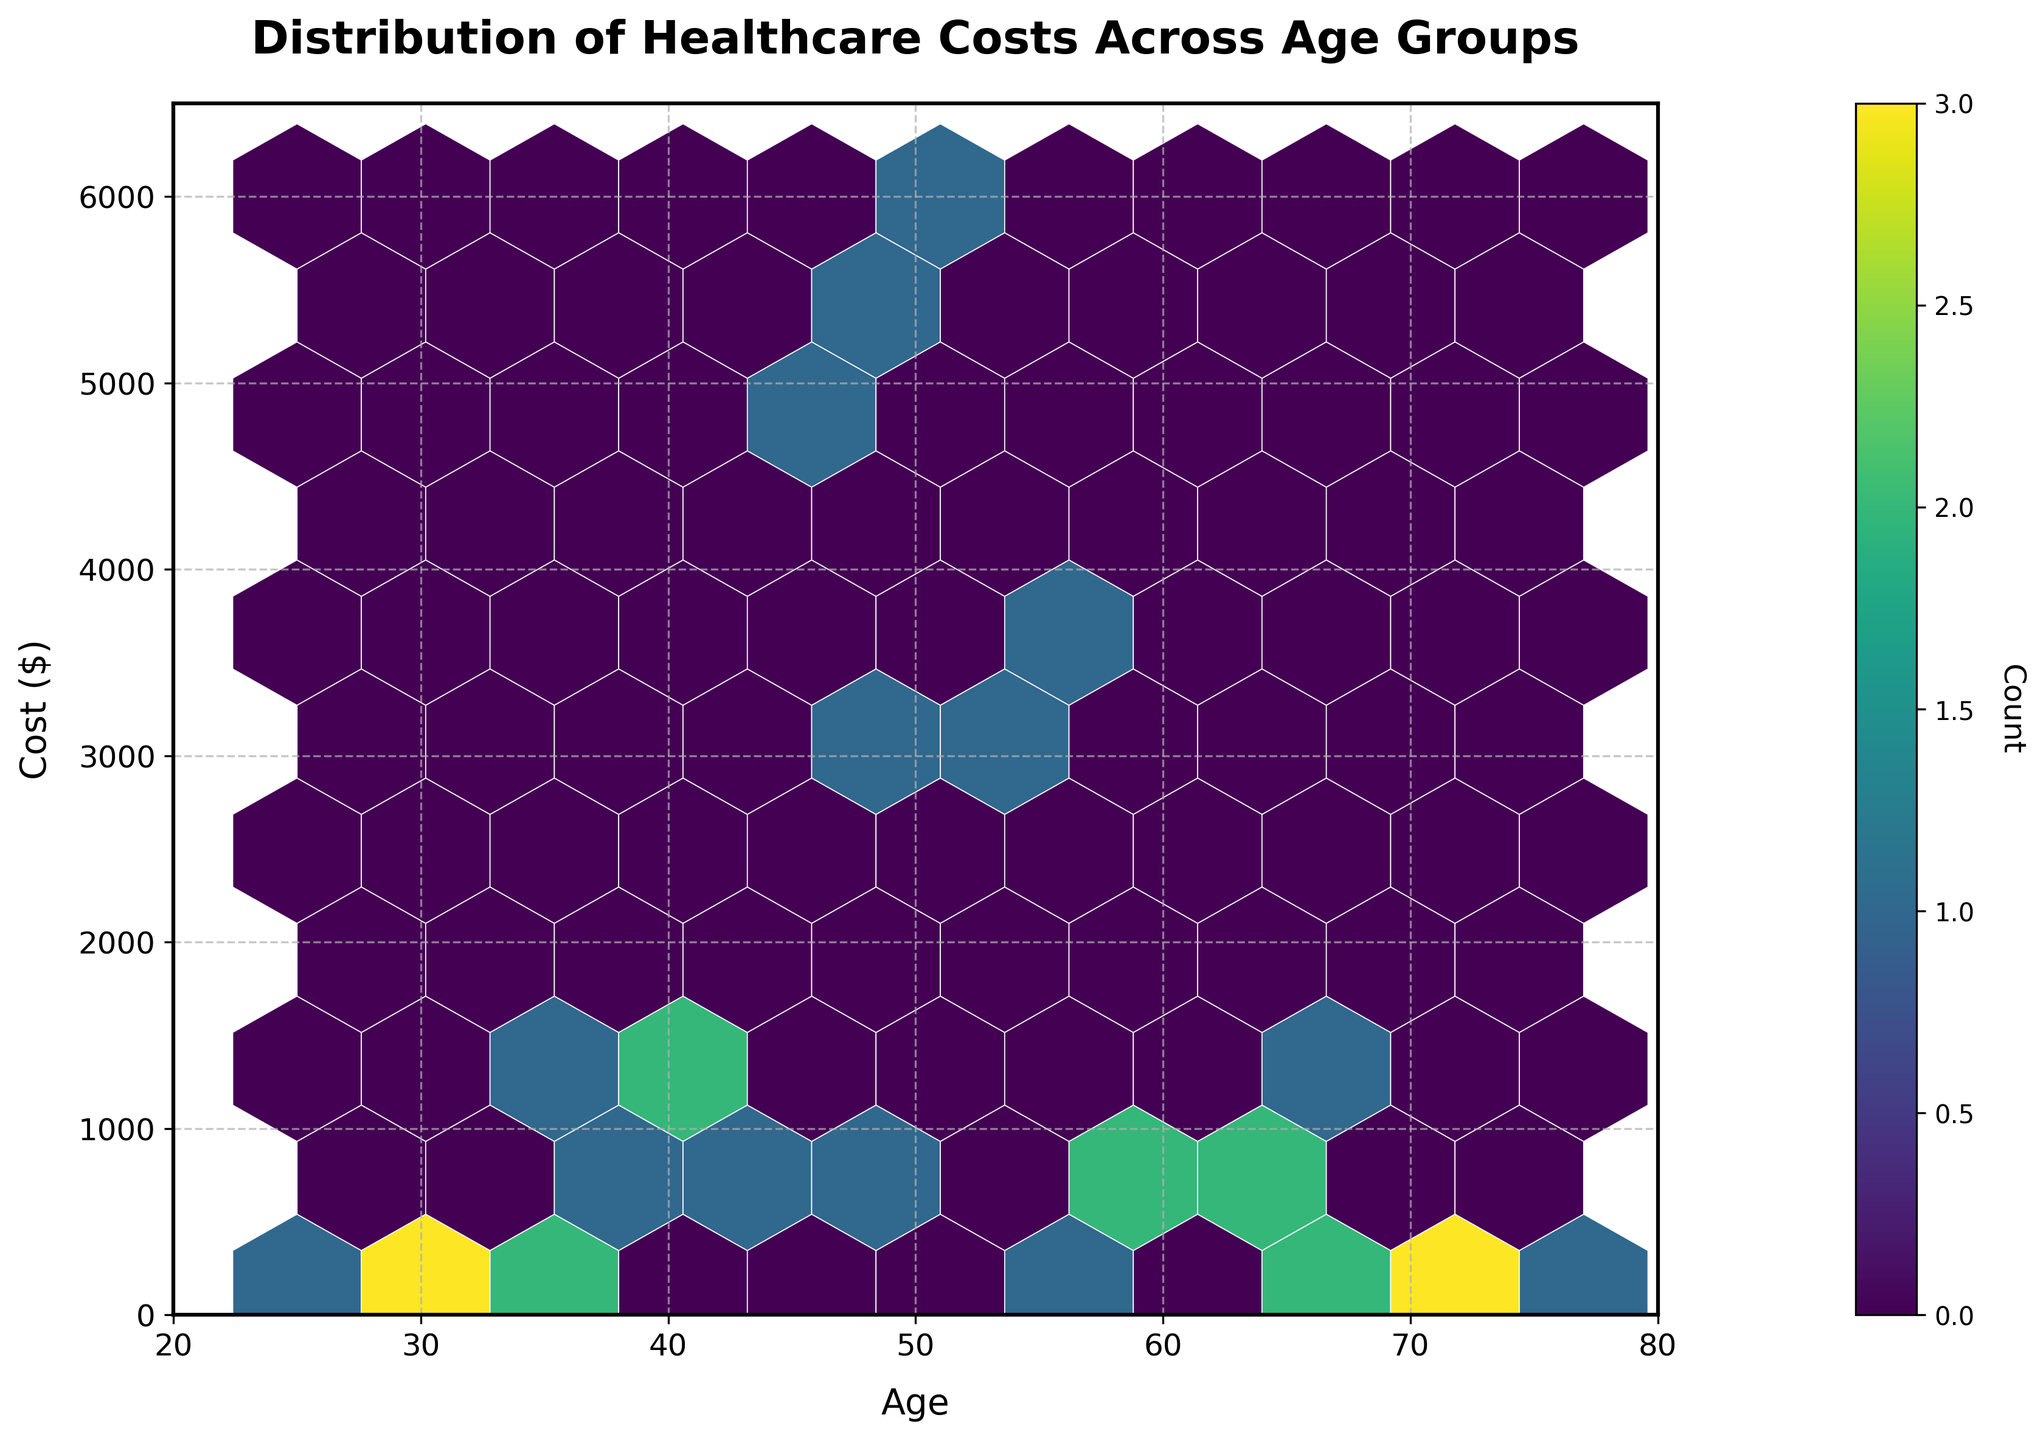What is the title of the figure? The title of the figure is prominently displayed at the top of the plot. It indicates the main subject of the visualization.
Answer: Distribution of Healthcare Costs Across Age Groups What does the color intensity in the plot represent? In hexbin plots, the color intensity usually represents the count of data points within each hexagon. A color bar is present to show this mapping. The more intense the color, the higher the count of data points.
Answer: Count of healthcare costs in each hexagon What are the axes labels in the plot? The axes labels describe what the x-axis and y-axis represent. These labels are usually positioned just outside the axis lines. By looking at these labels, we can understand what dimensions or measures are plotted.
Answer: Age (x-axis) and Cost ($) (y-axis) What is the general trend of healthcare costs with age? To see the trend, look at how the location and concentration of hexagons change along the x-axis (age) and y-axis (cost). Generally, we might observe if costs increase, decrease, or remain constant as age advances.
Answer: Generally, healthcare costs increase with age Which age group has the highest frequency of data points in terms of healthcare costs between $500 - $1500? Look for the most color-intense hexagons in the specified cost range on the y-axis and check the corresponding age groups on the x-axis.
Answer: Age group around 45-50 years Which age group has the lowest overall healthcare costs? Find the range on the x-axis (age) where the y-axis (cost) values are consistently at their minimum, supported by lighter or fewer hexagons.
Answer: 25-30 years Comparing age groups 40 and 70, which one generally incurs higher costs? Focus on the hexagons corresponding to ages 40 and 70. Compare the vertical spread and color intensity of these hexagons to see which age group has higher costs.
Answer: Age group 40 generally incurs higher costs How many age groups have their highest healthcare costs above $4000? Identify hexagons above the $4000 mark on the y-axis and count the distinct age groups on the x-axis that these hexagons fall into.
Answer: Approximately 3 age groups What is the average healthcare cost for people under 50 based on the plot? Examine the range of costs for people under 50, then visually estimate the central tendency (mean) of these costs by observing where the hexagons are most concentrated on the y-axis.
Answer: Around $1000 to $2000 Which service type might be contributing the most to overall healthcare costs, based on the age group patterns and cost ranges? Examine the cost ranges for different age groups and infer which service types (from related experience) typically fall within those ranges. This provides insights into which service types might be contributing most. For instance, high costs around older age groups may suggest services like Hospitalization or Outpatient Surgery.
Answer: Likely Hospitalization or Outpatient Surgery 